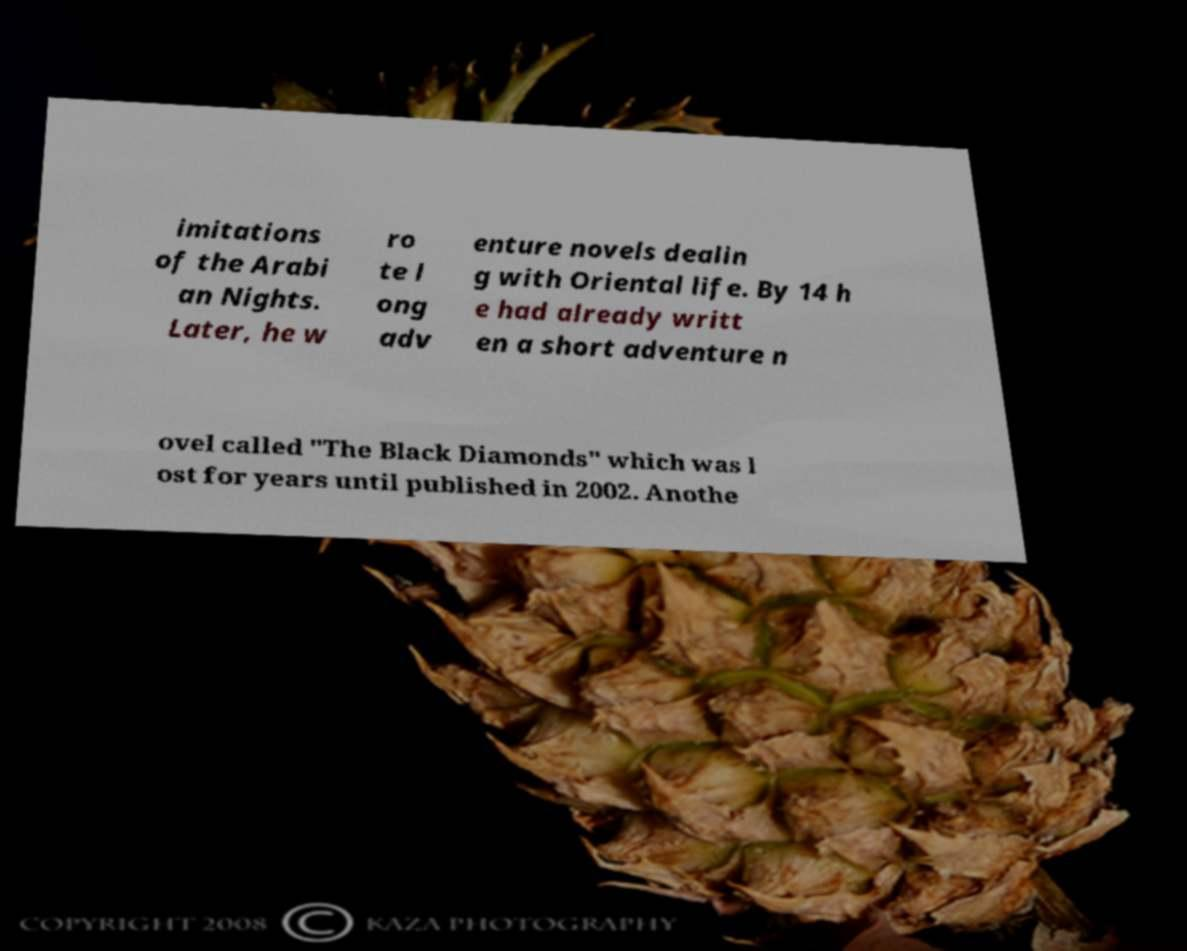There's text embedded in this image that I need extracted. Can you transcribe it verbatim? imitations of the Arabi an Nights. Later, he w ro te l ong adv enture novels dealin g with Oriental life. By 14 h e had already writt en a short adventure n ovel called "The Black Diamonds" which was l ost for years until published in 2002. Anothe 